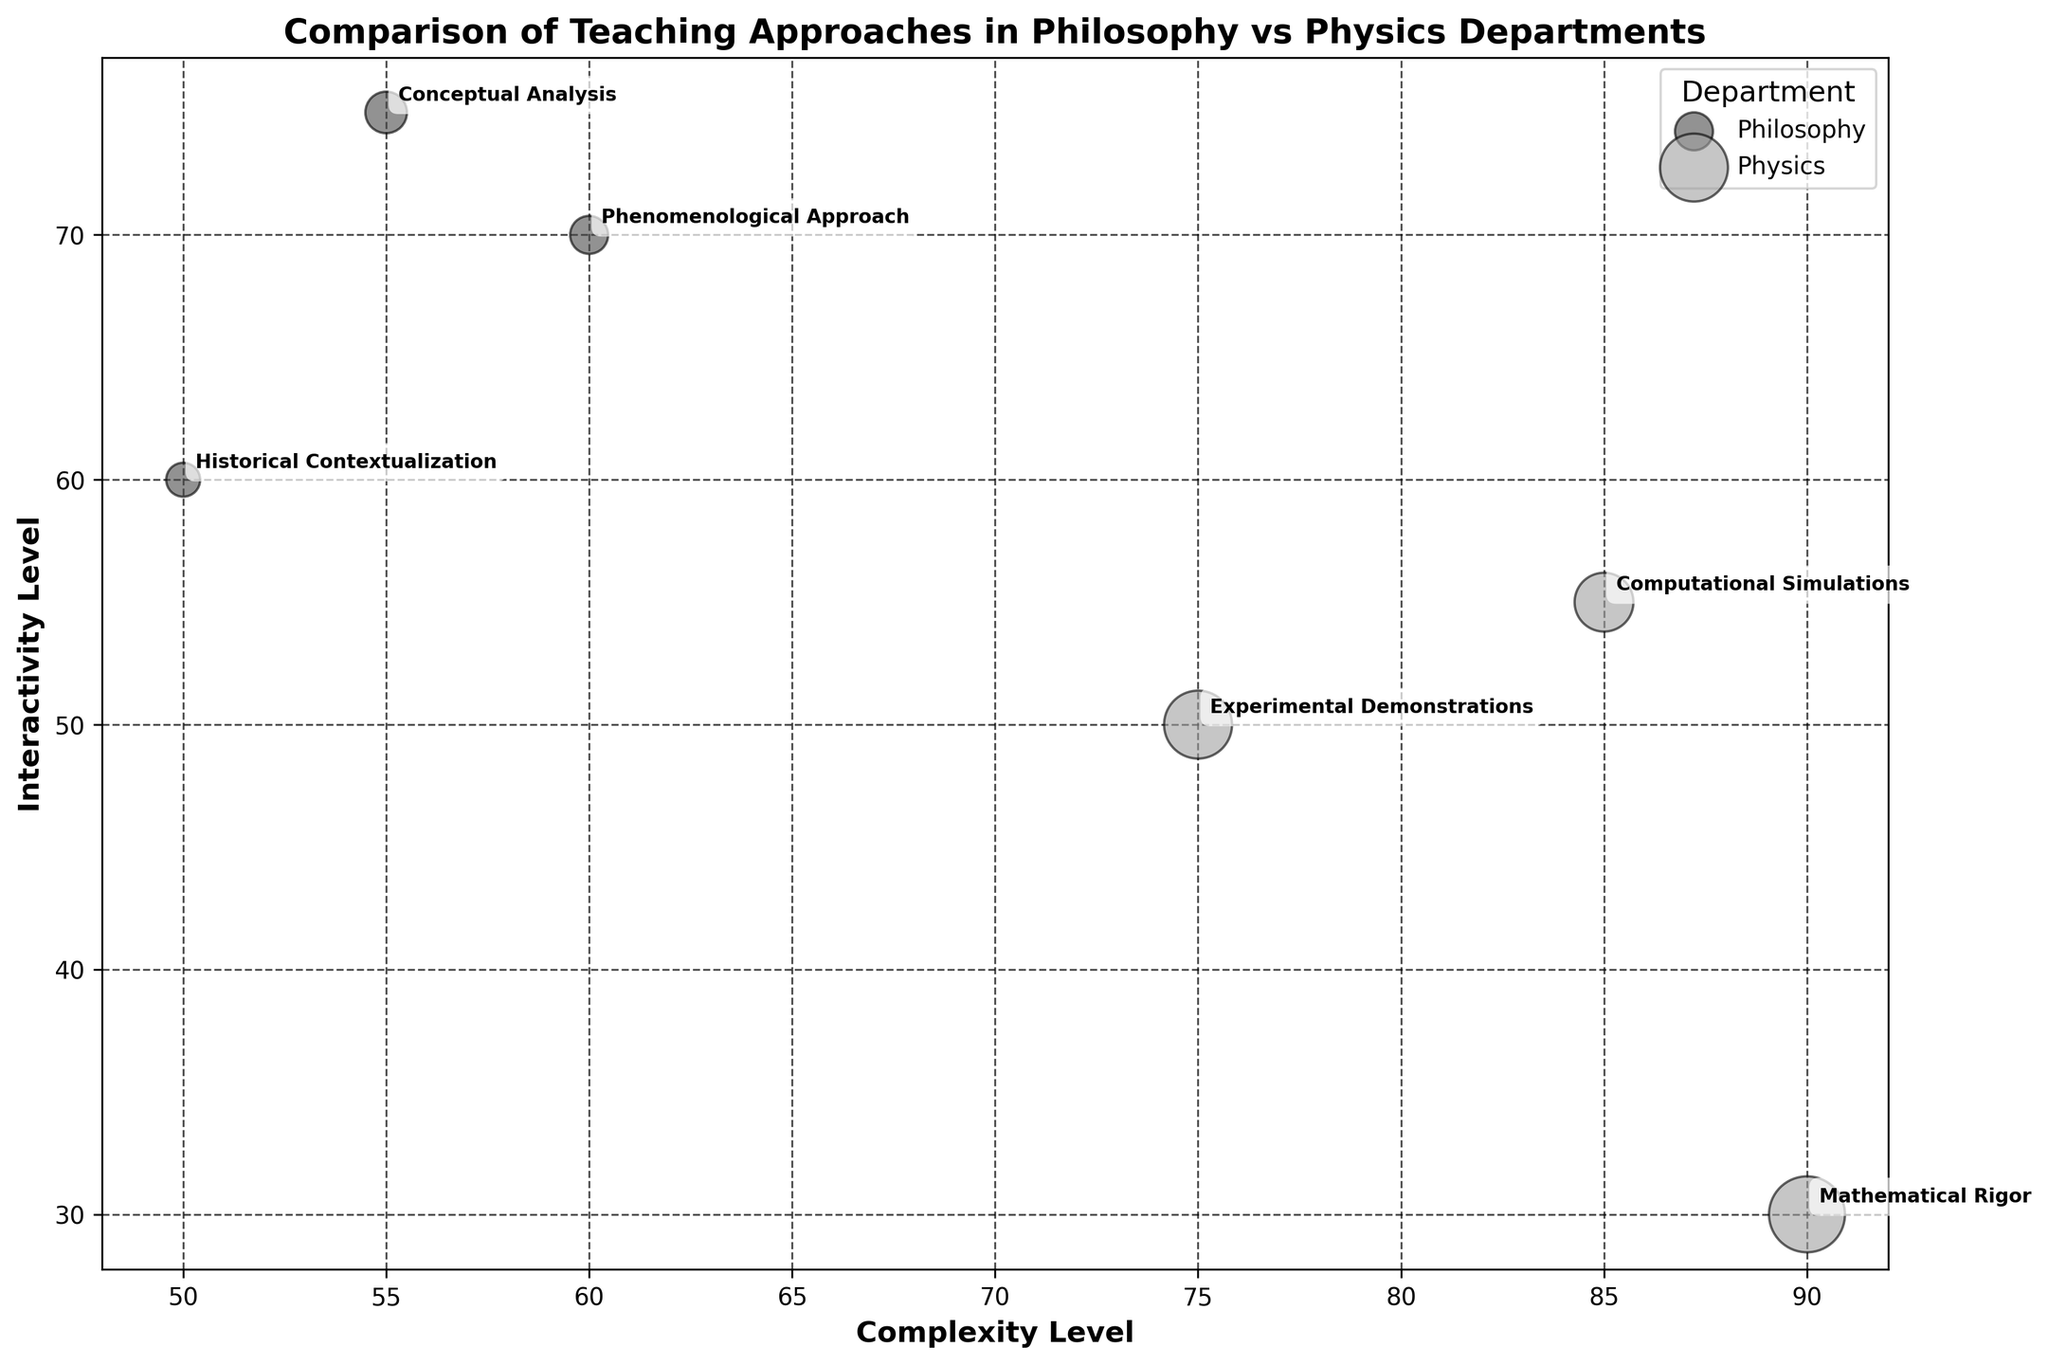What is the title of the figure? The title is usually located at the top of the figure. By reading the text in the title area, you can determine the title of the figure.
Answer: Comparison of Teaching Approaches in Philosophy vs Physics Departments Which teaching approach has the highest interactivity level in the Philosophy Department? Look at the bubbles labeled with different teaching approaches within the Philosophy Department category and compare their interactivity values.
Answer: Conceptual Analysis Which department has larger class sizes in general? Compare the sizes of the bubbles for both Philosophy and Physics departments. Bubbles representing larger class sizes will be bigger.
Answer: Physics How many distinct teaching approaches are depicted in the Physics Department? Identify all unique bubbles labeled with different teaching approaches within the Physics Department category by counting them.
Answer: 3 What is the interactivity level of the "Experimental Demonstrations" teaching approach in the Physics Department? Find the bubble labeled "Experimental Demonstrations" in the Physics Department and note its corresponding position on the interactivity level axis.
Answer: 50 Which teaching approach has the lowest complexity level in the Philosophy Department? Among the bubbles within the Philosophy Department, find the one that is plotted lowest on the complexity level axis.
Answer: Historical Contextualization How does the interactivity level of "Mathematical Rigor" compare to that of "Computational Simulations" in the Physics Department? Locate the bubbles labeled "Mathematical Rigor" and "Computational Simulations" in the Physics Department and compare their positions on the interactivity level axis.
Answer: Mathematical Rigor has a lower interactivity level Which teaching approach integrates the highest philosophical content in Philosophy Department? Locate the bubbles in the Philosophy Department and read the annotations to find the approach with the highest philosophical integration.
Answer: Phenomenological Approach Is the teaching approach with the highest complexity level in the Physics Department also the one with the largest class size? Identify the bubble with the highest complexity level in the Physics Department and check if it has the largest size among Physics bubbles.
Answer: Yes What is the average interactivity level of the teaching approaches in the Philosophy Department? Calculate the mean of the interactivity levels for the identified teaching approaches within the Philosophy Department by summing their values and dividing by the number of approaches.
Answer: (70 + 60 + 75) / 3 = 68 